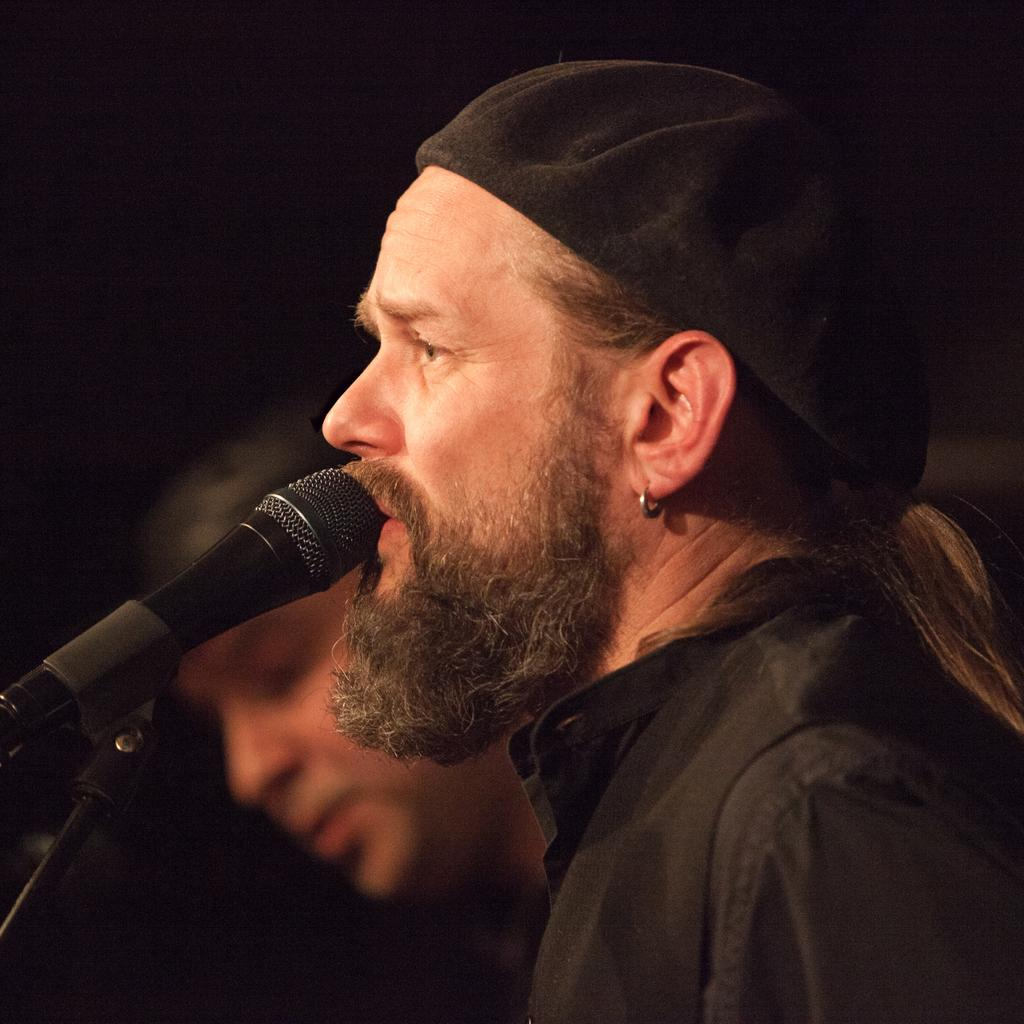What is the main subject in the foreground of the image? There is a man in the foreground of the image. What is the man in the foreground doing? The man in the foreground is talking into a microphone. Can you describe the scene in the background of the image? There is another man in the background of the image. What type of stitch is the man in the foreground using to hold the microphone? The man in the foreground is not using a stitch to hold the microphone; he is simply talking into it. Can you tell me the color of the manager's tongue in the image? There is no manager present in the image, and therefore no tongue to describe. 